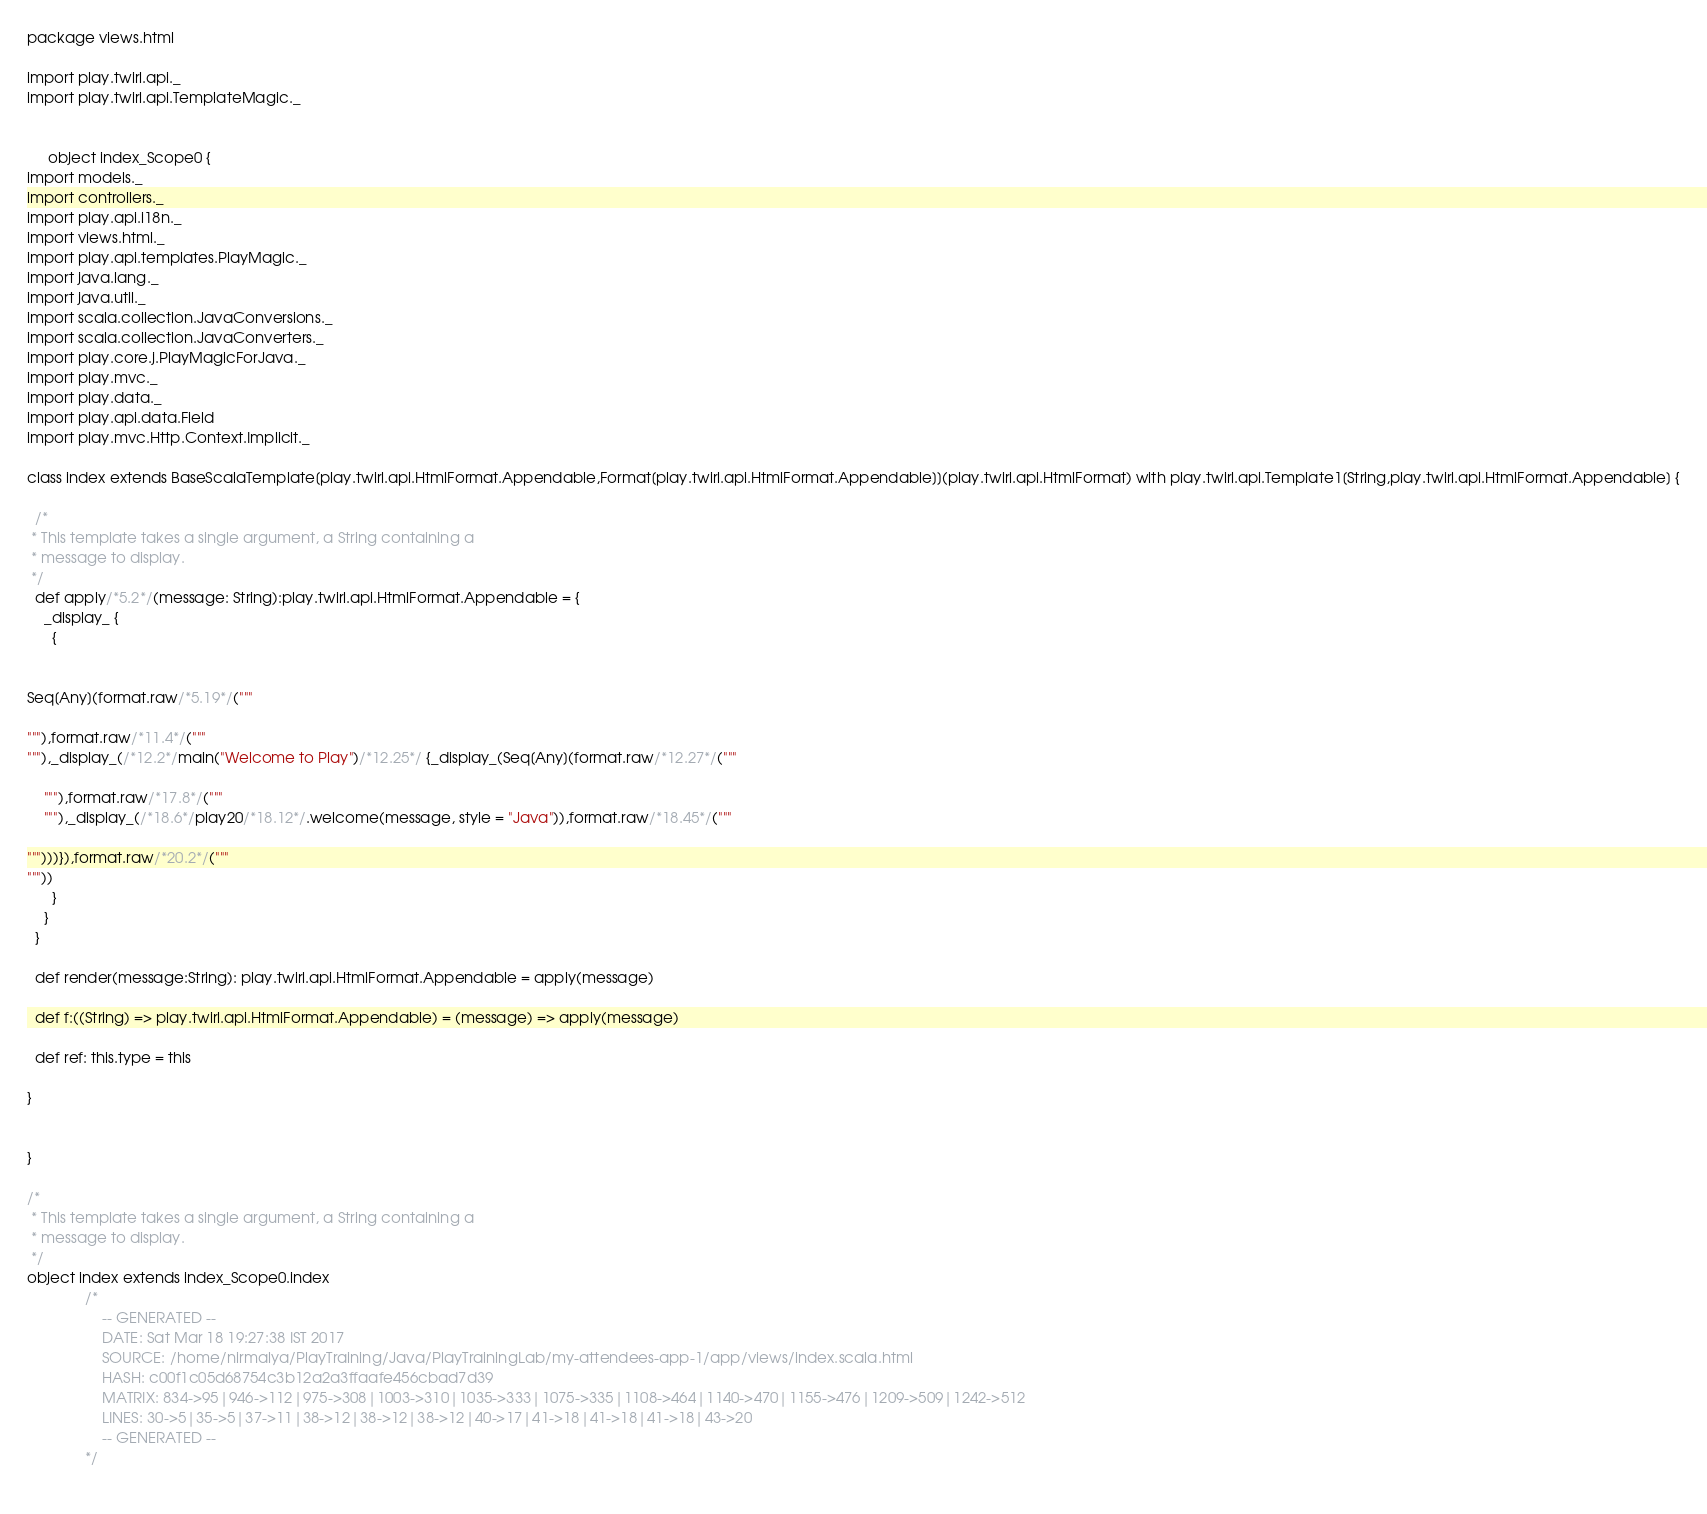Convert code to text. <code><loc_0><loc_0><loc_500><loc_500><_Scala_>
package views.html

import play.twirl.api._
import play.twirl.api.TemplateMagic._


     object index_Scope0 {
import models._
import controllers._
import play.api.i18n._
import views.html._
import play.api.templates.PlayMagic._
import java.lang._
import java.util._
import scala.collection.JavaConversions._
import scala.collection.JavaConverters._
import play.core.j.PlayMagicForJava._
import play.mvc._
import play.data._
import play.api.data.Field
import play.mvc.Http.Context.Implicit._

class index extends BaseScalaTemplate[play.twirl.api.HtmlFormat.Appendable,Format[play.twirl.api.HtmlFormat.Appendable]](play.twirl.api.HtmlFormat) with play.twirl.api.Template1[String,play.twirl.api.HtmlFormat.Appendable] {

  /*
 * This template takes a single argument, a String containing a
 * message to display.
 */
  def apply/*5.2*/(message: String):play.twirl.api.HtmlFormat.Appendable = {
    _display_ {
      {


Seq[Any](format.raw/*5.19*/("""

"""),format.raw/*11.4*/("""
"""),_display_(/*12.2*/main("Welcome to Play")/*12.25*/ {_display_(Seq[Any](format.raw/*12.27*/("""

    """),format.raw/*17.8*/("""
    """),_display_(/*18.6*/play20/*18.12*/.welcome(message, style = "Java")),format.raw/*18.45*/("""

""")))}),format.raw/*20.2*/("""
"""))
      }
    }
  }

  def render(message:String): play.twirl.api.HtmlFormat.Appendable = apply(message)

  def f:((String) => play.twirl.api.HtmlFormat.Appendable) = (message) => apply(message)

  def ref: this.type = this

}


}

/*
 * This template takes a single argument, a String containing a
 * message to display.
 */
object index extends index_Scope0.index
              /*
                  -- GENERATED --
                  DATE: Sat Mar 18 19:27:38 IST 2017
                  SOURCE: /home/nirmalya/PlayTraining/Java/PlayTrainingLab/my-attendees-app-1/app/views/index.scala.html
                  HASH: c00f1c05d68754c3b12a2a3ffaafe456cbad7d39
                  MATRIX: 834->95|946->112|975->308|1003->310|1035->333|1075->335|1108->464|1140->470|1155->476|1209->509|1242->512
                  LINES: 30->5|35->5|37->11|38->12|38->12|38->12|40->17|41->18|41->18|41->18|43->20
                  -- GENERATED --
              */
          </code> 